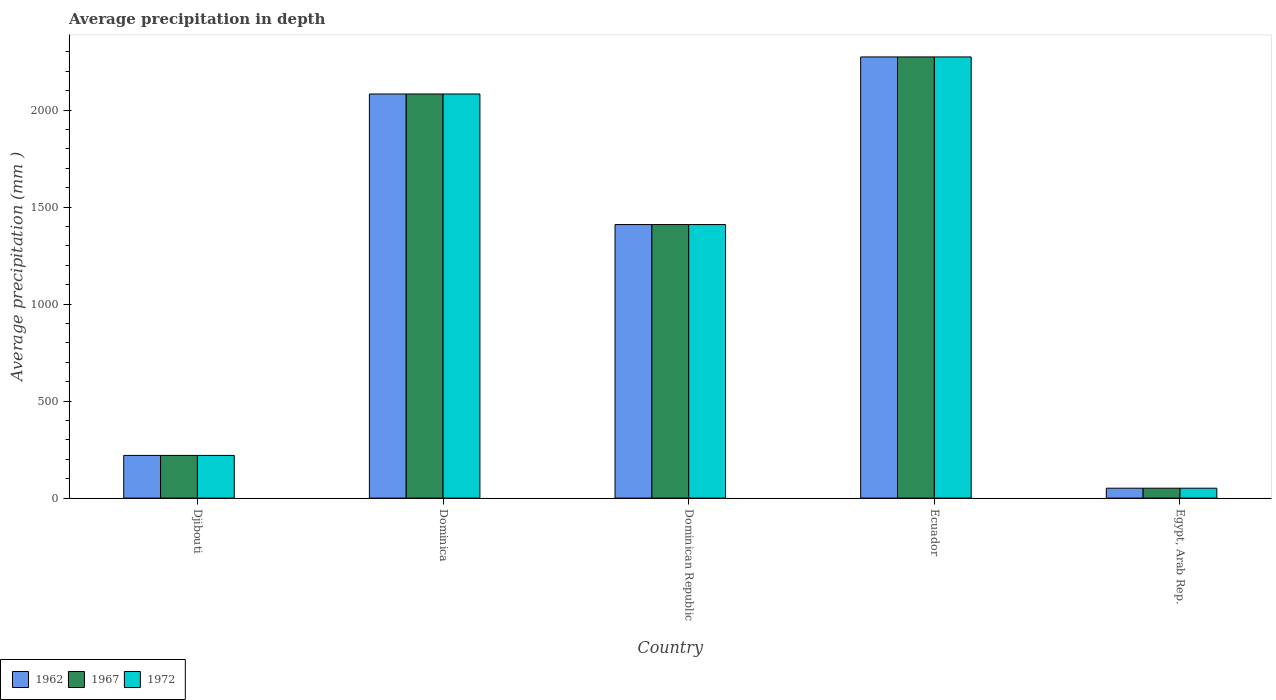How many different coloured bars are there?
Provide a succinct answer. 3. How many bars are there on the 3rd tick from the right?
Make the answer very short. 3. What is the label of the 2nd group of bars from the left?
Your answer should be very brief. Dominica. In how many cases, is the number of bars for a given country not equal to the number of legend labels?
Keep it short and to the point. 0. What is the average precipitation in 1967 in Dominica?
Keep it short and to the point. 2083. Across all countries, what is the maximum average precipitation in 1967?
Give a very brief answer. 2274. Across all countries, what is the minimum average precipitation in 1967?
Offer a terse response. 51. In which country was the average precipitation in 1967 maximum?
Give a very brief answer. Ecuador. In which country was the average precipitation in 1972 minimum?
Make the answer very short. Egypt, Arab Rep. What is the total average precipitation in 1967 in the graph?
Give a very brief answer. 6038. What is the difference between the average precipitation in 1967 in Ecuador and that in Egypt, Arab Rep.?
Keep it short and to the point. 2223. What is the difference between the average precipitation in 1967 in Djibouti and the average precipitation in 1962 in Ecuador?
Your answer should be compact. -2054. What is the average average precipitation in 1962 per country?
Ensure brevity in your answer.  1207.6. What is the ratio of the average precipitation in 1972 in Djibouti to that in Dominica?
Provide a short and direct response. 0.11. What is the difference between the highest and the second highest average precipitation in 1962?
Make the answer very short. 191. What is the difference between the highest and the lowest average precipitation in 1962?
Your response must be concise. 2223. In how many countries, is the average precipitation in 1972 greater than the average average precipitation in 1972 taken over all countries?
Provide a succinct answer. 3. What does the 2nd bar from the left in Ecuador represents?
Provide a succinct answer. 1967. How many bars are there?
Your answer should be very brief. 15. How many countries are there in the graph?
Your answer should be compact. 5. Does the graph contain any zero values?
Keep it short and to the point. No. How many legend labels are there?
Provide a short and direct response. 3. How are the legend labels stacked?
Provide a succinct answer. Horizontal. What is the title of the graph?
Give a very brief answer. Average precipitation in depth. Does "1996" appear as one of the legend labels in the graph?
Your response must be concise. No. What is the label or title of the X-axis?
Offer a very short reply. Country. What is the label or title of the Y-axis?
Offer a terse response. Average precipitation (mm ). What is the Average precipitation (mm ) in 1962 in Djibouti?
Offer a terse response. 220. What is the Average precipitation (mm ) in 1967 in Djibouti?
Your answer should be very brief. 220. What is the Average precipitation (mm ) in 1972 in Djibouti?
Your answer should be compact. 220. What is the Average precipitation (mm ) of 1962 in Dominica?
Your answer should be very brief. 2083. What is the Average precipitation (mm ) of 1967 in Dominica?
Make the answer very short. 2083. What is the Average precipitation (mm ) of 1972 in Dominica?
Your answer should be compact. 2083. What is the Average precipitation (mm ) in 1962 in Dominican Republic?
Your response must be concise. 1410. What is the Average precipitation (mm ) of 1967 in Dominican Republic?
Offer a terse response. 1410. What is the Average precipitation (mm ) of 1972 in Dominican Republic?
Provide a succinct answer. 1410. What is the Average precipitation (mm ) of 1962 in Ecuador?
Give a very brief answer. 2274. What is the Average precipitation (mm ) in 1967 in Ecuador?
Give a very brief answer. 2274. What is the Average precipitation (mm ) of 1972 in Ecuador?
Your response must be concise. 2274. What is the Average precipitation (mm ) of 1967 in Egypt, Arab Rep.?
Make the answer very short. 51. What is the Average precipitation (mm ) in 1972 in Egypt, Arab Rep.?
Your answer should be compact. 51. Across all countries, what is the maximum Average precipitation (mm ) in 1962?
Ensure brevity in your answer.  2274. Across all countries, what is the maximum Average precipitation (mm ) of 1967?
Offer a terse response. 2274. Across all countries, what is the maximum Average precipitation (mm ) in 1972?
Your answer should be very brief. 2274. Across all countries, what is the minimum Average precipitation (mm ) of 1962?
Your answer should be compact. 51. Across all countries, what is the minimum Average precipitation (mm ) in 1967?
Your answer should be very brief. 51. What is the total Average precipitation (mm ) of 1962 in the graph?
Offer a very short reply. 6038. What is the total Average precipitation (mm ) in 1967 in the graph?
Ensure brevity in your answer.  6038. What is the total Average precipitation (mm ) in 1972 in the graph?
Keep it short and to the point. 6038. What is the difference between the Average precipitation (mm ) of 1962 in Djibouti and that in Dominica?
Offer a very short reply. -1863. What is the difference between the Average precipitation (mm ) of 1967 in Djibouti and that in Dominica?
Give a very brief answer. -1863. What is the difference between the Average precipitation (mm ) in 1972 in Djibouti and that in Dominica?
Keep it short and to the point. -1863. What is the difference between the Average precipitation (mm ) in 1962 in Djibouti and that in Dominican Republic?
Offer a terse response. -1190. What is the difference between the Average precipitation (mm ) in 1967 in Djibouti and that in Dominican Republic?
Your answer should be very brief. -1190. What is the difference between the Average precipitation (mm ) in 1972 in Djibouti and that in Dominican Republic?
Give a very brief answer. -1190. What is the difference between the Average precipitation (mm ) of 1962 in Djibouti and that in Ecuador?
Your response must be concise. -2054. What is the difference between the Average precipitation (mm ) in 1967 in Djibouti and that in Ecuador?
Your response must be concise. -2054. What is the difference between the Average precipitation (mm ) in 1972 in Djibouti and that in Ecuador?
Give a very brief answer. -2054. What is the difference between the Average precipitation (mm ) of 1962 in Djibouti and that in Egypt, Arab Rep.?
Your response must be concise. 169. What is the difference between the Average precipitation (mm ) of 1967 in Djibouti and that in Egypt, Arab Rep.?
Ensure brevity in your answer.  169. What is the difference between the Average precipitation (mm ) of 1972 in Djibouti and that in Egypt, Arab Rep.?
Your answer should be very brief. 169. What is the difference between the Average precipitation (mm ) of 1962 in Dominica and that in Dominican Republic?
Your response must be concise. 673. What is the difference between the Average precipitation (mm ) in 1967 in Dominica and that in Dominican Republic?
Provide a short and direct response. 673. What is the difference between the Average precipitation (mm ) of 1972 in Dominica and that in Dominican Republic?
Give a very brief answer. 673. What is the difference between the Average precipitation (mm ) in 1962 in Dominica and that in Ecuador?
Keep it short and to the point. -191. What is the difference between the Average precipitation (mm ) in 1967 in Dominica and that in Ecuador?
Your answer should be very brief. -191. What is the difference between the Average precipitation (mm ) in 1972 in Dominica and that in Ecuador?
Offer a very short reply. -191. What is the difference between the Average precipitation (mm ) of 1962 in Dominica and that in Egypt, Arab Rep.?
Ensure brevity in your answer.  2032. What is the difference between the Average precipitation (mm ) of 1967 in Dominica and that in Egypt, Arab Rep.?
Offer a terse response. 2032. What is the difference between the Average precipitation (mm ) in 1972 in Dominica and that in Egypt, Arab Rep.?
Provide a short and direct response. 2032. What is the difference between the Average precipitation (mm ) of 1962 in Dominican Republic and that in Ecuador?
Offer a terse response. -864. What is the difference between the Average precipitation (mm ) in 1967 in Dominican Republic and that in Ecuador?
Your response must be concise. -864. What is the difference between the Average precipitation (mm ) in 1972 in Dominican Republic and that in Ecuador?
Ensure brevity in your answer.  -864. What is the difference between the Average precipitation (mm ) in 1962 in Dominican Republic and that in Egypt, Arab Rep.?
Make the answer very short. 1359. What is the difference between the Average precipitation (mm ) in 1967 in Dominican Republic and that in Egypt, Arab Rep.?
Your response must be concise. 1359. What is the difference between the Average precipitation (mm ) in 1972 in Dominican Republic and that in Egypt, Arab Rep.?
Your answer should be very brief. 1359. What is the difference between the Average precipitation (mm ) in 1962 in Ecuador and that in Egypt, Arab Rep.?
Your answer should be compact. 2223. What is the difference between the Average precipitation (mm ) in 1967 in Ecuador and that in Egypt, Arab Rep.?
Keep it short and to the point. 2223. What is the difference between the Average precipitation (mm ) of 1972 in Ecuador and that in Egypt, Arab Rep.?
Your response must be concise. 2223. What is the difference between the Average precipitation (mm ) in 1962 in Djibouti and the Average precipitation (mm ) in 1967 in Dominica?
Provide a short and direct response. -1863. What is the difference between the Average precipitation (mm ) in 1962 in Djibouti and the Average precipitation (mm ) in 1972 in Dominica?
Make the answer very short. -1863. What is the difference between the Average precipitation (mm ) of 1967 in Djibouti and the Average precipitation (mm ) of 1972 in Dominica?
Provide a short and direct response. -1863. What is the difference between the Average precipitation (mm ) in 1962 in Djibouti and the Average precipitation (mm ) in 1967 in Dominican Republic?
Ensure brevity in your answer.  -1190. What is the difference between the Average precipitation (mm ) in 1962 in Djibouti and the Average precipitation (mm ) in 1972 in Dominican Republic?
Your answer should be compact. -1190. What is the difference between the Average precipitation (mm ) of 1967 in Djibouti and the Average precipitation (mm ) of 1972 in Dominican Republic?
Your response must be concise. -1190. What is the difference between the Average precipitation (mm ) of 1962 in Djibouti and the Average precipitation (mm ) of 1967 in Ecuador?
Offer a very short reply. -2054. What is the difference between the Average precipitation (mm ) in 1962 in Djibouti and the Average precipitation (mm ) in 1972 in Ecuador?
Offer a very short reply. -2054. What is the difference between the Average precipitation (mm ) in 1967 in Djibouti and the Average precipitation (mm ) in 1972 in Ecuador?
Make the answer very short. -2054. What is the difference between the Average precipitation (mm ) in 1962 in Djibouti and the Average precipitation (mm ) in 1967 in Egypt, Arab Rep.?
Make the answer very short. 169. What is the difference between the Average precipitation (mm ) in 1962 in Djibouti and the Average precipitation (mm ) in 1972 in Egypt, Arab Rep.?
Give a very brief answer. 169. What is the difference between the Average precipitation (mm ) of 1967 in Djibouti and the Average precipitation (mm ) of 1972 in Egypt, Arab Rep.?
Provide a succinct answer. 169. What is the difference between the Average precipitation (mm ) in 1962 in Dominica and the Average precipitation (mm ) in 1967 in Dominican Republic?
Make the answer very short. 673. What is the difference between the Average precipitation (mm ) in 1962 in Dominica and the Average precipitation (mm ) in 1972 in Dominican Republic?
Give a very brief answer. 673. What is the difference between the Average precipitation (mm ) of 1967 in Dominica and the Average precipitation (mm ) of 1972 in Dominican Republic?
Provide a succinct answer. 673. What is the difference between the Average precipitation (mm ) in 1962 in Dominica and the Average precipitation (mm ) in 1967 in Ecuador?
Keep it short and to the point. -191. What is the difference between the Average precipitation (mm ) of 1962 in Dominica and the Average precipitation (mm ) of 1972 in Ecuador?
Offer a very short reply. -191. What is the difference between the Average precipitation (mm ) in 1967 in Dominica and the Average precipitation (mm ) in 1972 in Ecuador?
Give a very brief answer. -191. What is the difference between the Average precipitation (mm ) of 1962 in Dominica and the Average precipitation (mm ) of 1967 in Egypt, Arab Rep.?
Make the answer very short. 2032. What is the difference between the Average precipitation (mm ) in 1962 in Dominica and the Average precipitation (mm ) in 1972 in Egypt, Arab Rep.?
Keep it short and to the point. 2032. What is the difference between the Average precipitation (mm ) in 1967 in Dominica and the Average precipitation (mm ) in 1972 in Egypt, Arab Rep.?
Provide a short and direct response. 2032. What is the difference between the Average precipitation (mm ) of 1962 in Dominican Republic and the Average precipitation (mm ) of 1967 in Ecuador?
Offer a very short reply. -864. What is the difference between the Average precipitation (mm ) of 1962 in Dominican Republic and the Average precipitation (mm ) of 1972 in Ecuador?
Give a very brief answer. -864. What is the difference between the Average precipitation (mm ) of 1967 in Dominican Republic and the Average precipitation (mm ) of 1972 in Ecuador?
Ensure brevity in your answer.  -864. What is the difference between the Average precipitation (mm ) in 1962 in Dominican Republic and the Average precipitation (mm ) in 1967 in Egypt, Arab Rep.?
Your answer should be very brief. 1359. What is the difference between the Average precipitation (mm ) of 1962 in Dominican Republic and the Average precipitation (mm ) of 1972 in Egypt, Arab Rep.?
Give a very brief answer. 1359. What is the difference between the Average precipitation (mm ) of 1967 in Dominican Republic and the Average precipitation (mm ) of 1972 in Egypt, Arab Rep.?
Offer a very short reply. 1359. What is the difference between the Average precipitation (mm ) in 1962 in Ecuador and the Average precipitation (mm ) in 1967 in Egypt, Arab Rep.?
Your answer should be very brief. 2223. What is the difference between the Average precipitation (mm ) of 1962 in Ecuador and the Average precipitation (mm ) of 1972 in Egypt, Arab Rep.?
Keep it short and to the point. 2223. What is the difference between the Average precipitation (mm ) of 1967 in Ecuador and the Average precipitation (mm ) of 1972 in Egypt, Arab Rep.?
Your answer should be very brief. 2223. What is the average Average precipitation (mm ) of 1962 per country?
Your response must be concise. 1207.6. What is the average Average precipitation (mm ) in 1967 per country?
Provide a succinct answer. 1207.6. What is the average Average precipitation (mm ) in 1972 per country?
Your answer should be compact. 1207.6. What is the difference between the Average precipitation (mm ) in 1962 and Average precipitation (mm ) in 1972 in Djibouti?
Keep it short and to the point. 0. What is the difference between the Average precipitation (mm ) in 1962 and Average precipitation (mm ) in 1972 in Dominica?
Make the answer very short. 0. What is the difference between the Average precipitation (mm ) of 1967 and Average precipitation (mm ) of 1972 in Dominica?
Give a very brief answer. 0. What is the difference between the Average precipitation (mm ) of 1962 and Average precipitation (mm ) of 1967 in Dominican Republic?
Ensure brevity in your answer.  0. What is the difference between the Average precipitation (mm ) in 1967 and Average precipitation (mm ) in 1972 in Dominican Republic?
Offer a very short reply. 0. What is the difference between the Average precipitation (mm ) of 1962 and Average precipitation (mm ) of 1967 in Ecuador?
Give a very brief answer. 0. What is the difference between the Average precipitation (mm ) in 1962 and Average precipitation (mm ) in 1972 in Ecuador?
Provide a short and direct response. 0. What is the difference between the Average precipitation (mm ) in 1962 and Average precipitation (mm ) in 1967 in Egypt, Arab Rep.?
Give a very brief answer. 0. What is the difference between the Average precipitation (mm ) of 1962 and Average precipitation (mm ) of 1972 in Egypt, Arab Rep.?
Make the answer very short. 0. What is the ratio of the Average precipitation (mm ) in 1962 in Djibouti to that in Dominica?
Make the answer very short. 0.11. What is the ratio of the Average precipitation (mm ) of 1967 in Djibouti to that in Dominica?
Offer a terse response. 0.11. What is the ratio of the Average precipitation (mm ) of 1972 in Djibouti to that in Dominica?
Offer a terse response. 0.11. What is the ratio of the Average precipitation (mm ) in 1962 in Djibouti to that in Dominican Republic?
Your response must be concise. 0.16. What is the ratio of the Average precipitation (mm ) in 1967 in Djibouti to that in Dominican Republic?
Offer a terse response. 0.16. What is the ratio of the Average precipitation (mm ) in 1972 in Djibouti to that in Dominican Republic?
Make the answer very short. 0.16. What is the ratio of the Average precipitation (mm ) in 1962 in Djibouti to that in Ecuador?
Your response must be concise. 0.1. What is the ratio of the Average precipitation (mm ) of 1967 in Djibouti to that in Ecuador?
Provide a short and direct response. 0.1. What is the ratio of the Average precipitation (mm ) in 1972 in Djibouti to that in Ecuador?
Provide a short and direct response. 0.1. What is the ratio of the Average precipitation (mm ) of 1962 in Djibouti to that in Egypt, Arab Rep.?
Provide a short and direct response. 4.31. What is the ratio of the Average precipitation (mm ) of 1967 in Djibouti to that in Egypt, Arab Rep.?
Provide a short and direct response. 4.31. What is the ratio of the Average precipitation (mm ) in 1972 in Djibouti to that in Egypt, Arab Rep.?
Offer a very short reply. 4.31. What is the ratio of the Average precipitation (mm ) in 1962 in Dominica to that in Dominican Republic?
Your answer should be compact. 1.48. What is the ratio of the Average precipitation (mm ) of 1967 in Dominica to that in Dominican Republic?
Provide a short and direct response. 1.48. What is the ratio of the Average precipitation (mm ) in 1972 in Dominica to that in Dominican Republic?
Keep it short and to the point. 1.48. What is the ratio of the Average precipitation (mm ) in 1962 in Dominica to that in Ecuador?
Provide a succinct answer. 0.92. What is the ratio of the Average precipitation (mm ) in 1967 in Dominica to that in Ecuador?
Offer a terse response. 0.92. What is the ratio of the Average precipitation (mm ) in 1972 in Dominica to that in Ecuador?
Ensure brevity in your answer.  0.92. What is the ratio of the Average precipitation (mm ) of 1962 in Dominica to that in Egypt, Arab Rep.?
Your answer should be compact. 40.84. What is the ratio of the Average precipitation (mm ) in 1967 in Dominica to that in Egypt, Arab Rep.?
Provide a succinct answer. 40.84. What is the ratio of the Average precipitation (mm ) of 1972 in Dominica to that in Egypt, Arab Rep.?
Make the answer very short. 40.84. What is the ratio of the Average precipitation (mm ) in 1962 in Dominican Republic to that in Ecuador?
Your answer should be compact. 0.62. What is the ratio of the Average precipitation (mm ) in 1967 in Dominican Republic to that in Ecuador?
Your answer should be very brief. 0.62. What is the ratio of the Average precipitation (mm ) in 1972 in Dominican Republic to that in Ecuador?
Provide a short and direct response. 0.62. What is the ratio of the Average precipitation (mm ) in 1962 in Dominican Republic to that in Egypt, Arab Rep.?
Your answer should be very brief. 27.65. What is the ratio of the Average precipitation (mm ) of 1967 in Dominican Republic to that in Egypt, Arab Rep.?
Keep it short and to the point. 27.65. What is the ratio of the Average precipitation (mm ) in 1972 in Dominican Republic to that in Egypt, Arab Rep.?
Your answer should be very brief. 27.65. What is the ratio of the Average precipitation (mm ) in 1962 in Ecuador to that in Egypt, Arab Rep.?
Keep it short and to the point. 44.59. What is the ratio of the Average precipitation (mm ) of 1967 in Ecuador to that in Egypt, Arab Rep.?
Offer a terse response. 44.59. What is the ratio of the Average precipitation (mm ) in 1972 in Ecuador to that in Egypt, Arab Rep.?
Ensure brevity in your answer.  44.59. What is the difference between the highest and the second highest Average precipitation (mm ) of 1962?
Provide a short and direct response. 191. What is the difference between the highest and the second highest Average precipitation (mm ) of 1967?
Your response must be concise. 191. What is the difference between the highest and the second highest Average precipitation (mm ) of 1972?
Ensure brevity in your answer.  191. What is the difference between the highest and the lowest Average precipitation (mm ) in 1962?
Offer a terse response. 2223. What is the difference between the highest and the lowest Average precipitation (mm ) in 1967?
Make the answer very short. 2223. What is the difference between the highest and the lowest Average precipitation (mm ) of 1972?
Your answer should be very brief. 2223. 